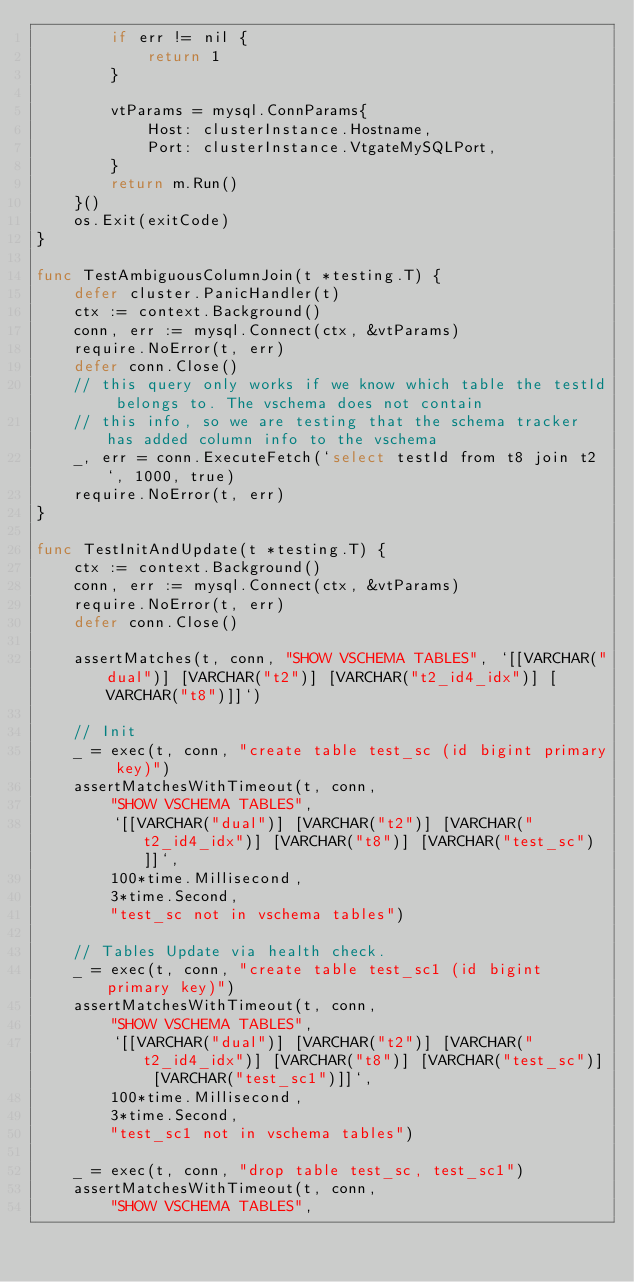Convert code to text. <code><loc_0><loc_0><loc_500><loc_500><_Go_>		if err != nil {
			return 1
		}

		vtParams = mysql.ConnParams{
			Host: clusterInstance.Hostname,
			Port: clusterInstance.VtgateMySQLPort,
		}
		return m.Run()
	}()
	os.Exit(exitCode)
}

func TestAmbiguousColumnJoin(t *testing.T) {
	defer cluster.PanicHandler(t)
	ctx := context.Background()
	conn, err := mysql.Connect(ctx, &vtParams)
	require.NoError(t, err)
	defer conn.Close()
	// this query only works if we know which table the testId belongs to. The vschema does not contain
	// this info, so we are testing that the schema tracker has added column info to the vschema
	_, err = conn.ExecuteFetch(`select testId from t8 join t2`, 1000, true)
	require.NoError(t, err)
}

func TestInitAndUpdate(t *testing.T) {
	ctx := context.Background()
	conn, err := mysql.Connect(ctx, &vtParams)
	require.NoError(t, err)
	defer conn.Close()

	assertMatches(t, conn, "SHOW VSCHEMA TABLES", `[[VARCHAR("dual")] [VARCHAR("t2")] [VARCHAR("t2_id4_idx")] [VARCHAR("t8")]]`)

	// Init
	_ = exec(t, conn, "create table test_sc (id bigint primary key)")
	assertMatchesWithTimeout(t, conn,
		"SHOW VSCHEMA TABLES",
		`[[VARCHAR("dual")] [VARCHAR("t2")] [VARCHAR("t2_id4_idx")] [VARCHAR("t8")] [VARCHAR("test_sc")]]`,
		100*time.Millisecond,
		3*time.Second,
		"test_sc not in vschema tables")

	// Tables Update via health check.
	_ = exec(t, conn, "create table test_sc1 (id bigint primary key)")
	assertMatchesWithTimeout(t, conn,
		"SHOW VSCHEMA TABLES",
		`[[VARCHAR("dual")] [VARCHAR("t2")] [VARCHAR("t2_id4_idx")] [VARCHAR("t8")] [VARCHAR("test_sc")] [VARCHAR("test_sc1")]]`,
		100*time.Millisecond,
		3*time.Second,
		"test_sc1 not in vschema tables")

	_ = exec(t, conn, "drop table test_sc, test_sc1")
	assertMatchesWithTimeout(t, conn,
		"SHOW VSCHEMA TABLES",</code> 